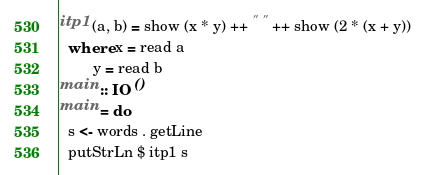<code> <loc_0><loc_0><loc_500><loc_500><_Haskell_>itp1 (a, b) = show (x * y) ++ " " ++ show (2 * (x + y))
  where x = read a
        y = read b
main :: IO ()
main = do
  s <- words . getLine
  putStrLn $ itp1 s</code> 